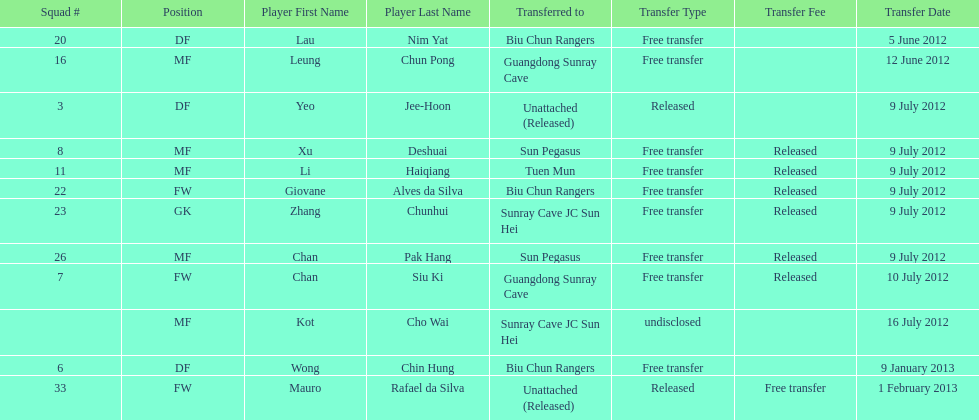Lau nim yat and giovane alves de silva where both transferred to which team? Biu Chun Rangers. 